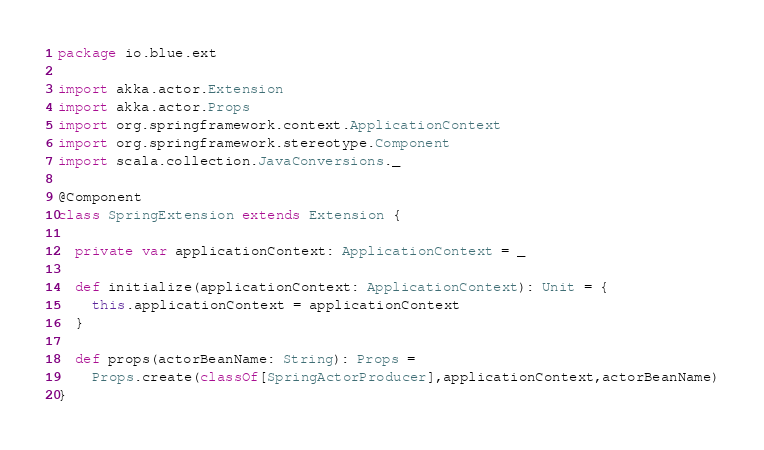Convert code to text. <code><loc_0><loc_0><loc_500><loc_500><_Scala_>package io.blue.ext

import akka.actor.Extension
import akka.actor.Props
import org.springframework.context.ApplicationContext
import org.springframework.stereotype.Component
import scala.collection.JavaConversions._

@Component
class SpringExtension extends Extension {

  private var applicationContext: ApplicationContext = _

  def initialize(applicationContext: ApplicationContext): Unit = {
    this.applicationContext = applicationContext
  }

  def props(actorBeanName: String): Props =
    Props.create(classOf[SpringActorProducer],applicationContext,actorBeanName)
}
</code> 